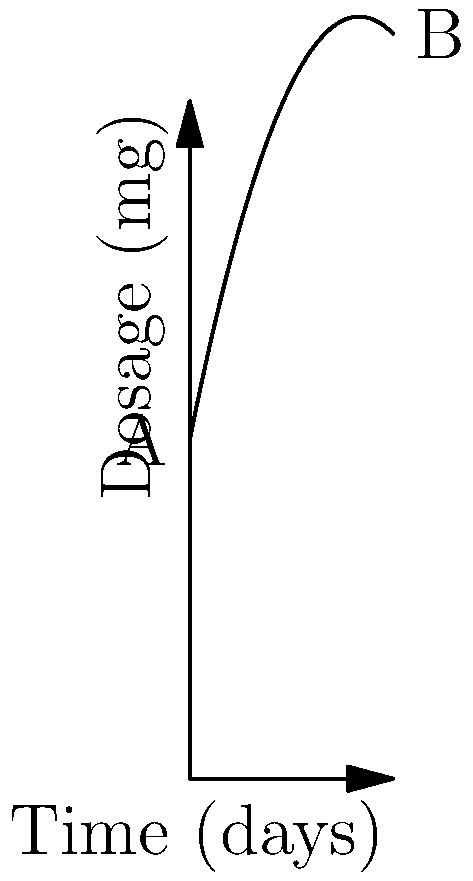The graph shows the medication dosage for an elderly patient over 30 days. If the dosage starts at 50 mg and follows the curve shown, calculate the average rate of change in dosage from day 0 to day 30. To calculate the average rate of change, we need to follow these steps:

1. Identify the initial and final points:
   Point A (0, 50) - initial dosage
   Point B (30, f(30)) - final dosage

2. Calculate the y-coordinate of point B:
   $f(30) = 50 + 5(30) - 0.1(30)^2 = 50 + 150 - 90 = 110$ mg

3. Use the average rate of change formula:
   Average rate of change = $\frac{\text{Change in y}}{\text{Change in x}} = \frac{\text{Final value - Initial value}}{\text{Final time - Initial time}}$

4. Substitute the values:
   $\text{Average rate of change} = \frac{110 - 50}{30 - 0} = \frac{60}{30} = 2$

Therefore, the average rate of change in dosage is 2 mg per day over the 30-day period.
Answer: 2 mg/day 